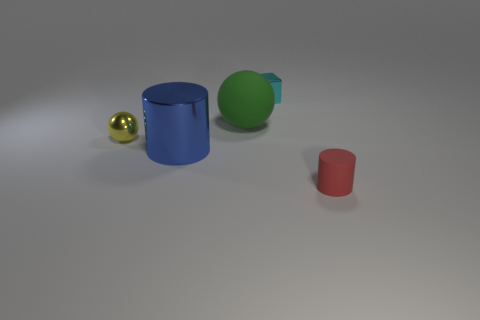Add 1 cyan metal objects. How many objects exist? 6 Subtract all cylinders. How many objects are left? 3 Subtract all blue cylinders. How many cylinders are left? 1 Subtract 1 cubes. How many cubes are left? 0 Subtract all purple blocks. Subtract all cyan cylinders. How many blocks are left? 1 Subtract all yellow cylinders. How many yellow spheres are left? 1 Subtract all tiny cyan metallic blocks. Subtract all green spheres. How many objects are left? 3 Add 3 small balls. How many small balls are left? 4 Add 4 tiny matte objects. How many tiny matte objects exist? 5 Subtract 1 yellow balls. How many objects are left? 4 